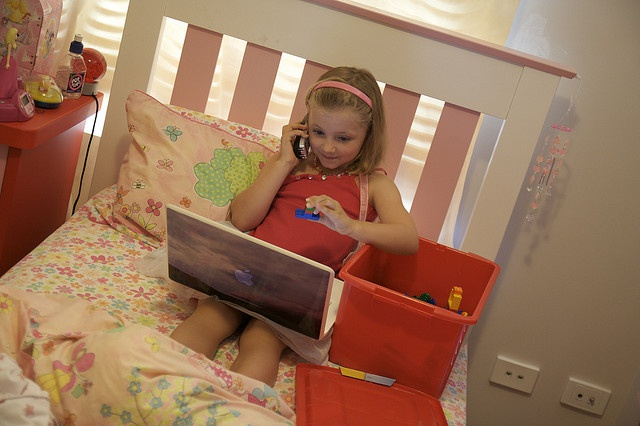Describe the objects in this image and their specific colors. I can see bed in brown, tan, and salmon tones, people in brown, gray, and maroon tones, laptop in brown, maroon, and black tones, bottle in brown, black, and tan tones, and cell phone in brown, black, maroon, and gray tones in this image. 